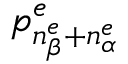<formula> <loc_0><loc_0><loc_500><loc_500>p _ { n _ { \beta } ^ { e } + n _ { \alpha } ^ { e } } ^ { e }</formula> 